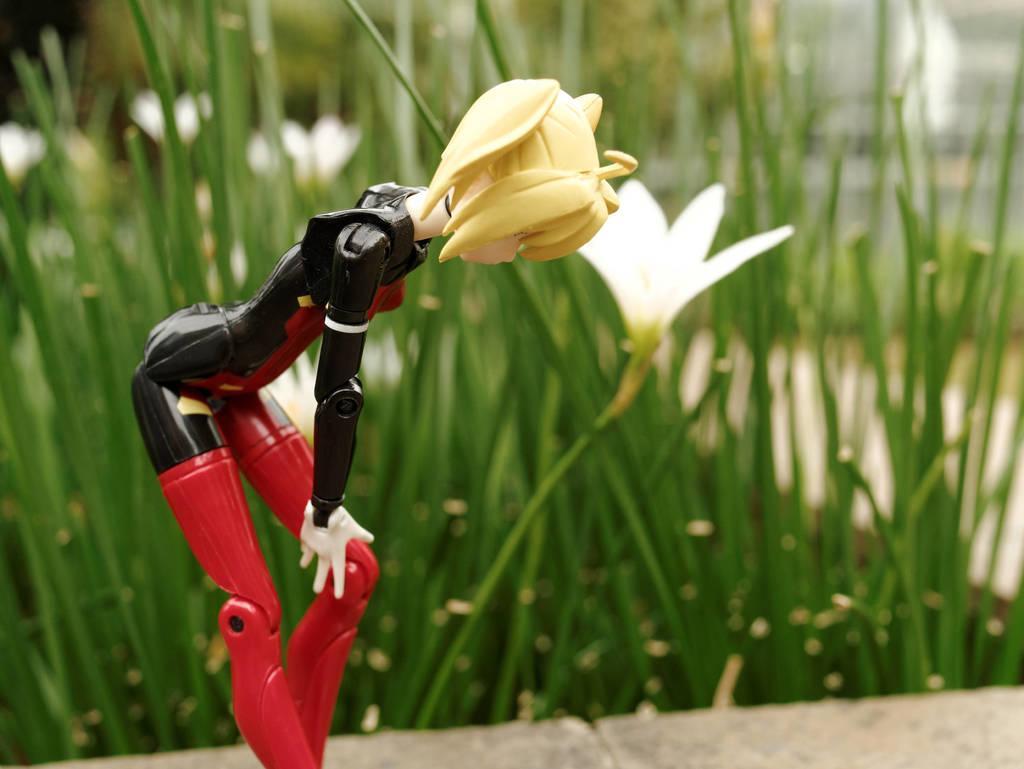Describe this image in one or two sentences. In this image in the foreground there is one toy, and in the background there are some plants and flowers. At the bottom there is walkway. 